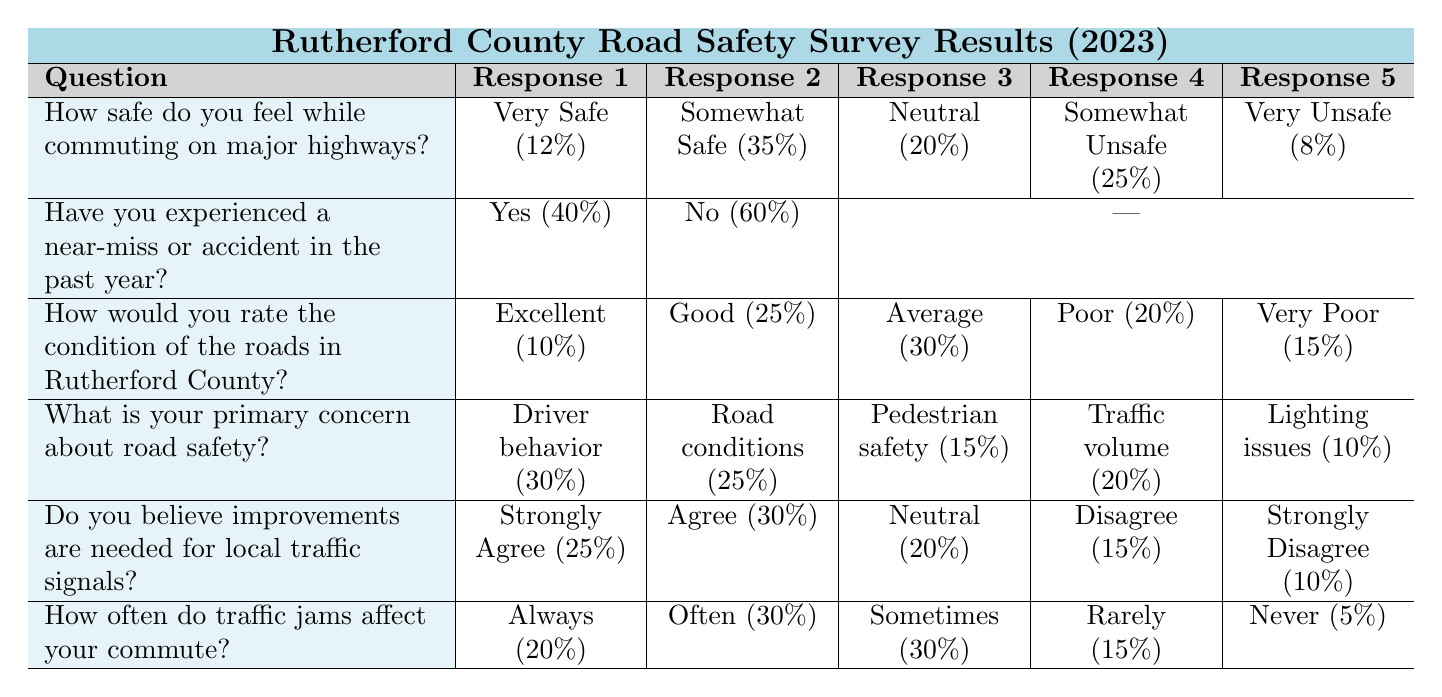How many respondents feel "Very Unsafe" while commuting on major highways? In the "How safe do you feel while commuting on major highways?" row, the "Very Unsafe" response shows a value of 8. Therefore, the number of respondents who feel "Very Unsafe" is 8.
Answer: 8 What percentage of respondents experienced a near-miss or accident in the past year? In the "Have you experienced a near-miss or accident in the past year?" row, 40 respondents answered "Yes," which represents 40% of the total.
Answer: 40% What is the total percentage of respondents who feel either "Somewhat Safe" or "Very Safe" on major highways? By adding the percentages of "Somewhat Safe" (35%) and "Very Safe" (12%), we get 35 + 12 = 47%. Therefore, 47% of respondents feel either "Somewhat Safe" or "Very Safe."
Answer: 47% Do the majority of respondents believe improvements are needed for local traffic signals? In the "Do you believe improvements are needed for local traffic signals?" row, if we add "Strongly Agree" (25%) and "Agree" (30%), we find that 55% of respondents think improvements are necessary, which is indeed a majority.
Answer: Yes What is the average rating for the condition of the roads (expressed as a percentage)? First, we calculate the total percentage by summing each response: 10 + 25 + 30 + 20 + 15 = 100%. Since there are 5 categories, we divide by 5 to find the average: 100% / 5 = 20%.
Answer: 20% What is the response percentage for "Traffic volume" as a primary concern about road safety? In the "What is your primary concern about road safety?" row, the "Traffic volume" response shows a value of 20%. This percentage indicates how many respondents chose this specific concern.
Answer: 20% How many respondents rated the roads in Rutherford County as "Poor"? In the "How would you rate the condition of the roads in Rutherford County?" row, the percentage for "Poor" is 20%, which indicates the proportion of respondents who gave this rating.
Answer: 20% What percentage of respondents feel that traffic jams "Never" affect their commute? In the "How often do traffic jams affect your commute?" row, "Never" shows a value of 5%. This percentage indicates a low impact from traffic jams on respondents' commutes.
Answer: 5% What is the combined percentage of respondents who feel "Somewhat Unsafe" and "Very Unsafe"? Adding "Somewhat Unsafe" (25%) and "Very Unsafe" (8%) gives 25 + 8 = 33%. Therefore, 33% of respondents express safety concerns when commuting on major highways.
Answer: 33% 